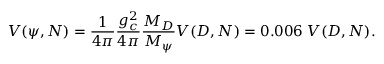<formula> <loc_0><loc_0><loc_500><loc_500>V ( \psi , N ) = { \frac { 1 } { 4 \pi } } { \frac { g _ { c } ^ { 2 } } { 4 \pi } } { \frac { M _ { D } } { M _ { \psi } } } V ( D , N ) = 0 . 0 0 6 \, V ( D , N ) .</formula> 